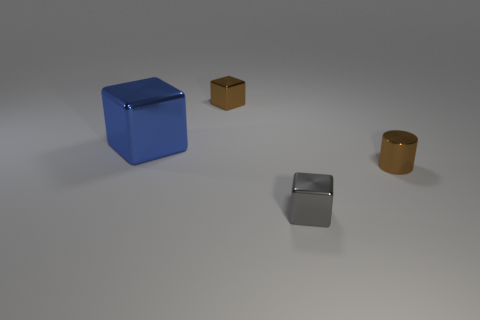There is a metallic cube in front of the tiny cylinder; is its color the same as the big shiny block?
Make the answer very short. No. What is the material of the tiny object behind the big block?
Keep it short and to the point. Metal. What size is the blue block?
Provide a succinct answer. Large. Does the small brown thing that is in front of the blue block have the same material as the tiny brown cube?
Offer a terse response. Yes. What number of large purple cylinders are there?
Give a very brief answer. 0. How many objects are brown cubes or cyan rubber cylinders?
Give a very brief answer. 1. What number of big shiny cubes are behind the brown cube to the right of the cube left of the brown cube?
Your response must be concise. 0. Is there any other thing that has the same color as the cylinder?
Offer a terse response. Yes. Does the thing to the right of the tiny gray block have the same color as the tiny cube that is behind the blue metal block?
Give a very brief answer. Yes. Is the number of tiny metal things that are on the right side of the brown metallic cylinder greater than the number of blue shiny cubes that are right of the large block?
Your answer should be compact. No. 